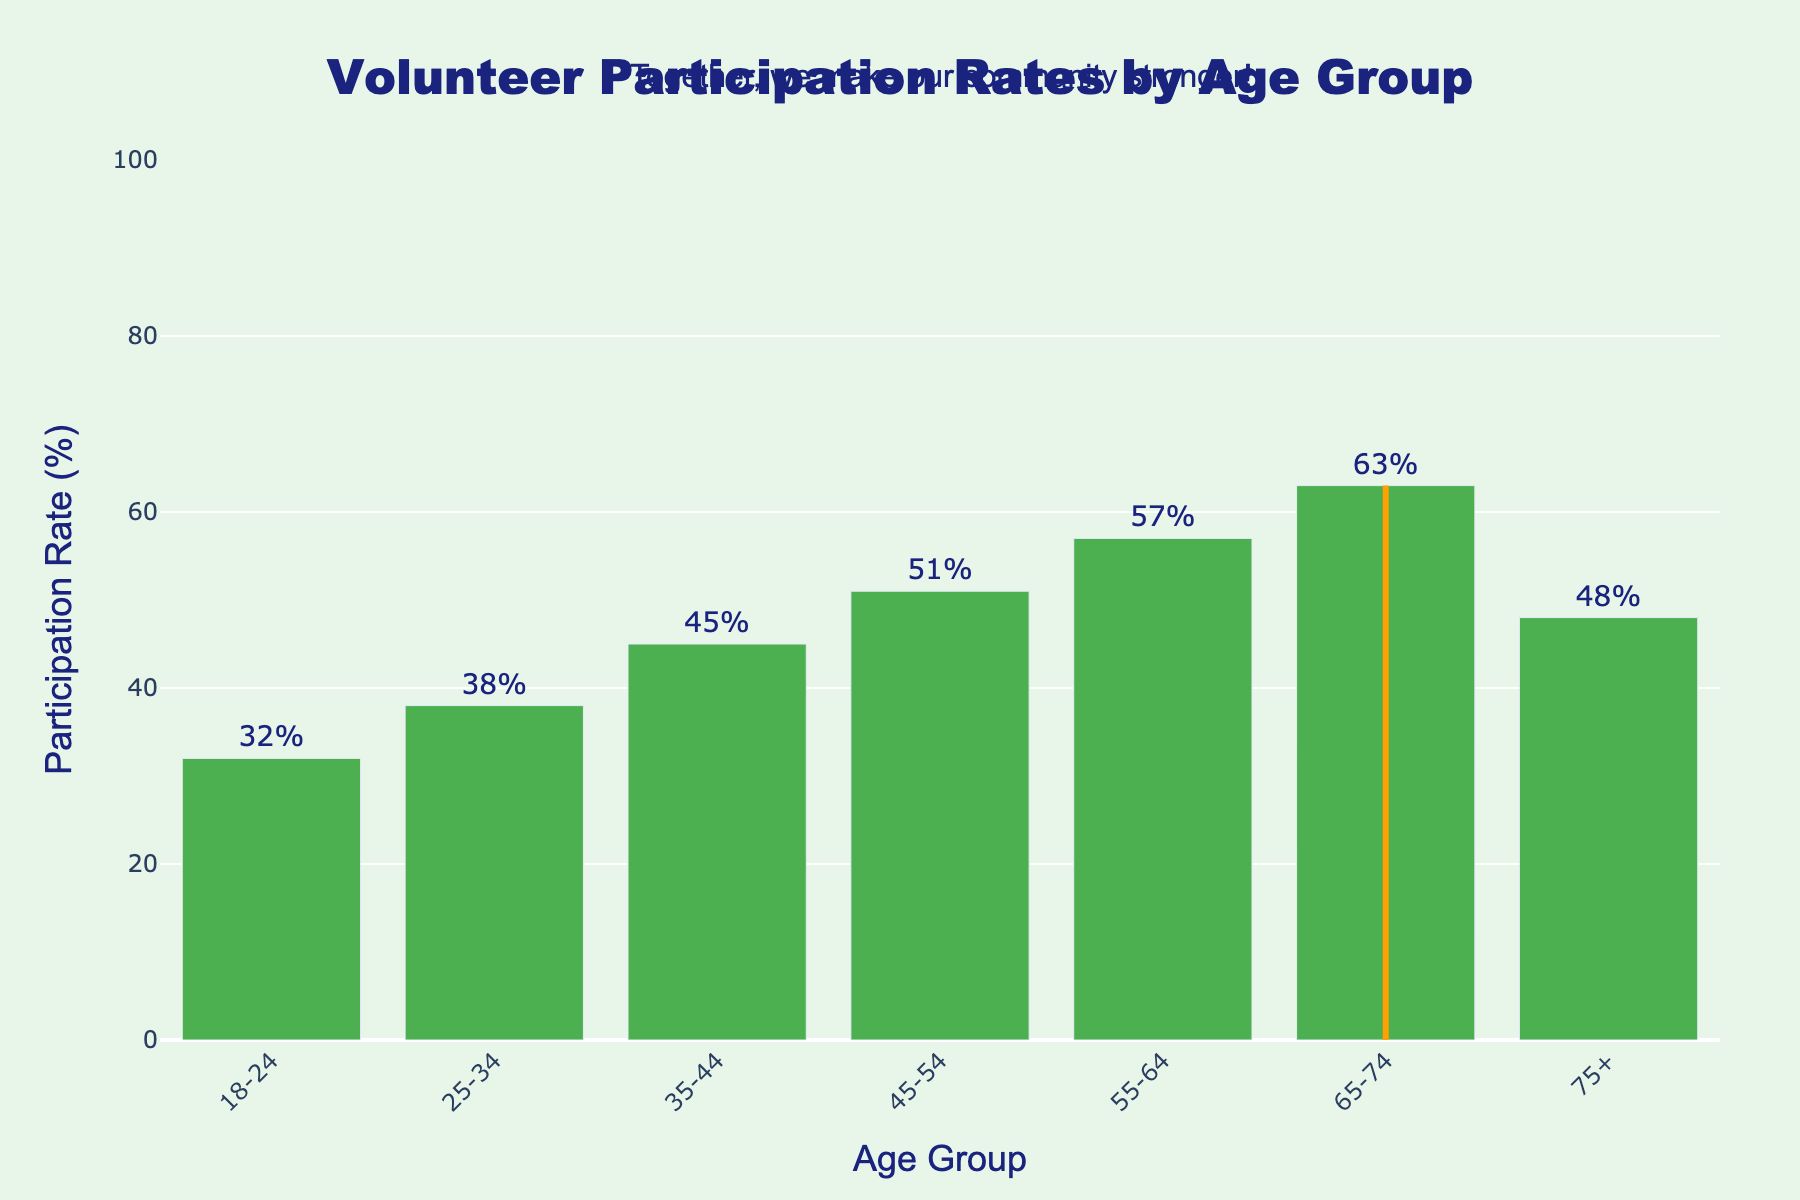What is the highest volunteer participation rate among the age groups? The bar chart shows various participation rates for different age groups. The highest bar represents the age group with the maximum rate. According to the figure, the age group 65-74 has the highest participation rate.
Answer: 63% Which age group has the lowest volunteer participation rate? The shortest bar represents the age group with the lowest rate. Based on the figure, the age group 18-24 has the lowest participation rate.
Answer: 32% How much higher is the volunteer participation rate for the age group 45-54 compared to the 25-34 age group? From the chart, identify the participation rates for both age groups: 45-54 and 25-34. The participation rates are 51% and 38%, respectively. The difference between them is 51% - 38% = 13%.
Answer: 13% Which age group, 55-64 or 75+, has a higher participation rate and by how much? Locate the participation rates for age groups 55-64 and 75+ on the chart. These rates are 57% and 48%, respectively. The difference is 57% - 48% = 9%.
Answer: 55-64 by 9% What's the median volunteer participation rate for all the age groups? List all the rates in ascending order and find the middle value. Participation rates sorted: 32, 38, 45, 48, 51, 57, 63. The middle value is the fourth number.
Answer: 48% By how many percentage points does the volunteer participation rate of the 65-74 age group exceed the average rate? Calculate the average participation rate (47.7%). The participation rate for the 65-74 age group is 63%. The difference is 63% - 47.71% = 15.29%.
Answer: 15.29% What color represents the bars in the bar chart? All the bars in the chart are consistently colored. Observing the chart, the bars are green.
Answer: Green Which age group has its participation rate highlighted by a rectangle shape? Identifying the age group whose bar is enclosed by a rectangle, it's clear from the figure that the 65-74 age group is highlighted.
Answer: 65-74 